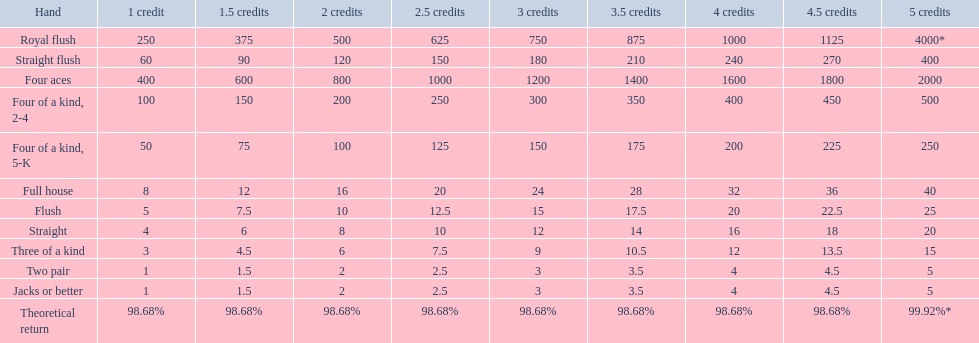Which hand is lower than straight flush? Four aces. Which hand is lower than four aces? Four of a kind, 2-4. Which hand is higher out of straight and flush? Flush. 